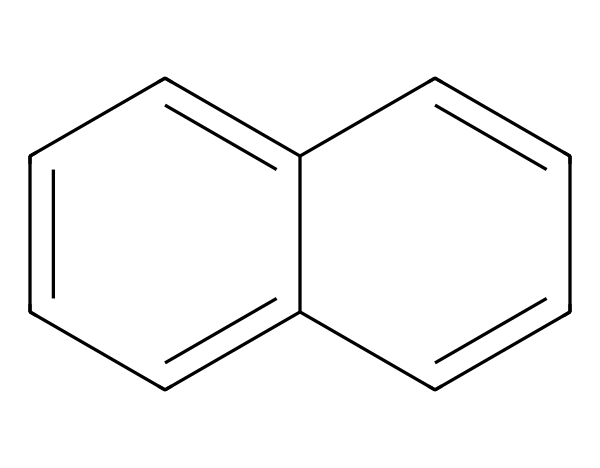What is the name of this compound? This compound's SMILES representation corresponds to naphthalene, which is characterized by its two fused benzene rings.
Answer: naphthalene How many carbon atoms are in this structure? Analyzing the SMILES representation, we can count the carbon atoms in the naphthalene structure, which has ten carbon atoms in total.
Answer: ten How many hydrogen atoms are attached to this compound? Each carbon in a benzene ring typically has one hydrogen atom; since naphthalene consists of two fused rings, the total number of hydrogen atoms is eight.
Answer: eight What type of hybridization do the carbon atoms in this structure exhibit? The carbon atoms in naphthalene are sp2 hybridized due to the presence of double bonds in the aromatic system.
Answer: sp2 Is this compound aromatic? Yes, naphthalene is considered an aromatic compound because it satisfies Huckel's rule and has a planar, cyclic structure with alternating double bonds.
Answer: yes What is the total number of π electrons in this compound? Naphthalene contains three double bonds, contributing six π electrons, which meets the criteria of Huckel's rule (4n + 2, where n = 1).
Answer: six What is the significance of the fused rings in this compound? The fused rings in naphthalene increase its stability and contribute to its unique chemical and physical properties as a polycyclic aromatic hydrocarbon.
Answer: stability 